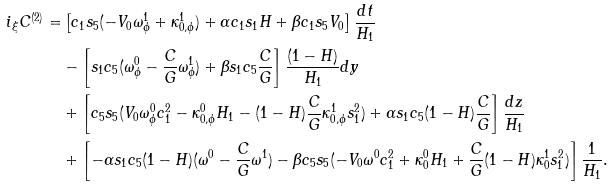Convert formula to latex. <formula><loc_0><loc_0><loc_500><loc_500>i _ { \xi } C ^ { ( 2 ) } = & \left [ c _ { 1 } s _ { 5 } ( - V _ { 0 } \omega ^ { 1 } _ { \phi } + \kappa ^ { 1 } _ { 0 , \phi } ) + \alpha c _ { 1 } s _ { 1 } H + \beta c _ { 1 } s _ { 5 } V _ { 0 } \right ] \frac { d t } { H _ { 1 } } \\ & - \left [ s _ { 1 } c _ { 5 } ( \omega ^ { 0 } _ { \phi } - \frac { C } { G } \omega ^ { 1 } _ { \phi } ) + \beta s _ { 1 } c _ { 5 } \frac { C } { G } \right ] \frac { ( 1 - H ) } { H _ { 1 } } d y \\ & + \left [ c _ { 5 } s _ { 5 } ( V _ { 0 } \omega ^ { 0 } _ { \phi } c _ { 1 } ^ { 2 } - \kappa ^ { 0 } _ { 0 , \phi } H _ { 1 } - ( 1 - H ) \frac { C } { G } \kappa ^ { 1 } _ { 0 , \phi } s _ { 1 } ^ { 2 } ) + \alpha s _ { 1 } c _ { 5 } ( 1 - H ) \frac { C } { G } \right ] \frac { d z } { H _ { 1 } } \\ & + \left [ - \alpha s _ { 1 } c _ { 5 } ( 1 - H ) ( \omega ^ { 0 } - \frac { C } { G } \omega ^ { 1 } ) - \beta c _ { 5 } s _ { 5 } ( - V _ { 0 } \omega ^ { 0 } c _ { 1 } ^ { 2 } + \kappa ^ { 0 } _ { 0 } H _ { 1 } + \frac { C } { G } ( 1 - H ) \kappa ^ { 1 } _ { 0 } s _ { 1 } ^ { 2 } ) \right ] \frac { 1 } { H _ { 1 } } .</formula> 